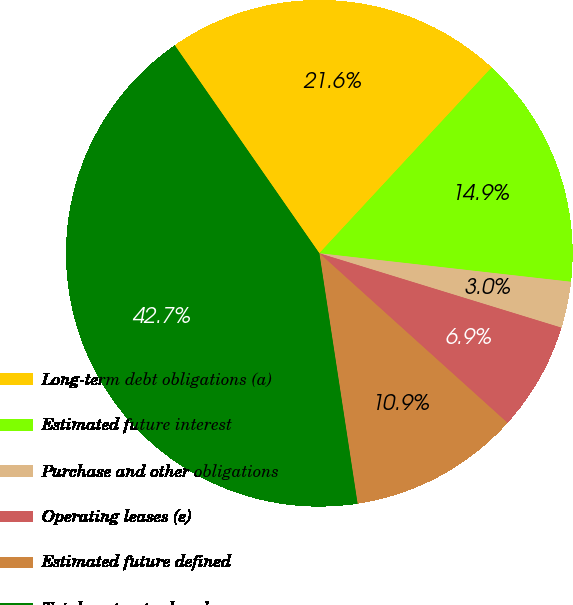Convert chart to OTSL. <chart><loc_0><loc_0><loc_500><loc_500><pie_chart><fcel>Long-term debt obligations (a)<fcel>Estimated future interest<fcel>Purchase and other obligations<fcel>Operating leases (e)<fcel>Estimated future defined<fcel>Total contractual cash<nl><fcel>21.57%<fcel>14.89%<fcel>2.95%<fcel>6.93%<fcel>10.91%<fcel>42.74%<nl></chart> 